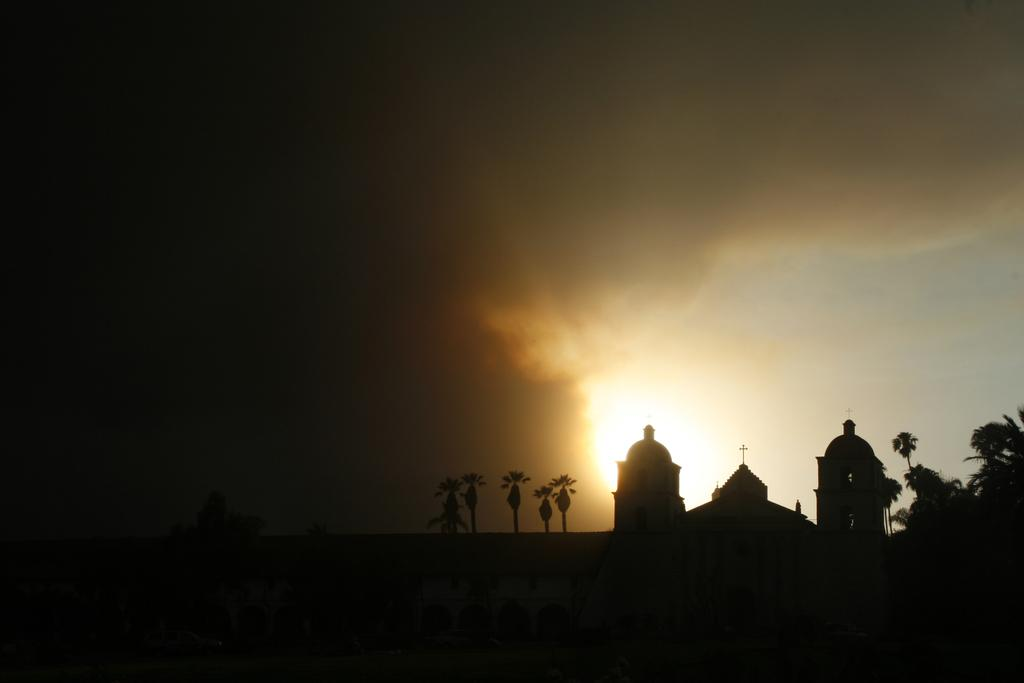What type of building is in the image? There is a church in the image. What other natural elements can be seen in the image? There are trees in the image. What time of day is suggested by the image? The sunset visible in the background of the image suggests that it is late afternoon or early evening. What type of advice can be heard coming from the church in the image? There is no indication in the image that any advice is being given, as it is a static image of a church and its surroundings. 